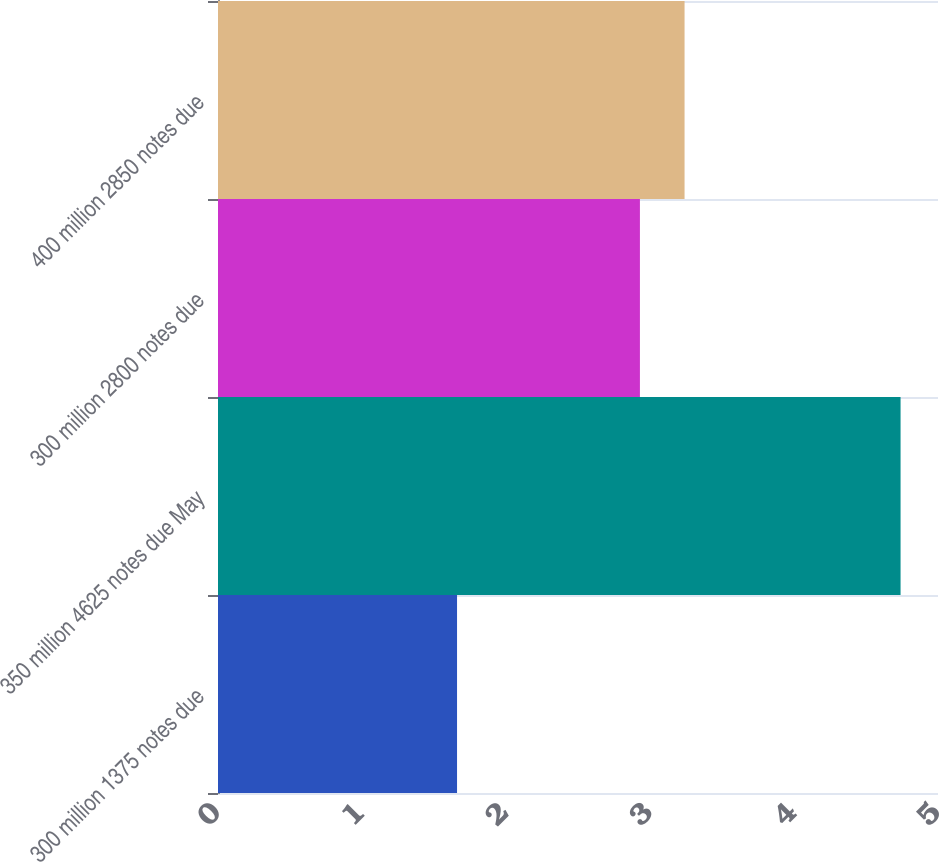Convert chart to OTSL. <chart><loc_0><loc_0><loc_500><loc_500><bar_chart><fcel>300 million 1375 notes due<fcel>350 million 4625 notes due May<fcel>300 million 2800 notes due<fcel>400 million 2850 notes due<nl><fcel>1.66<fcel>4.74<fcel>2.93<fcel>3.24<nl></chart> 